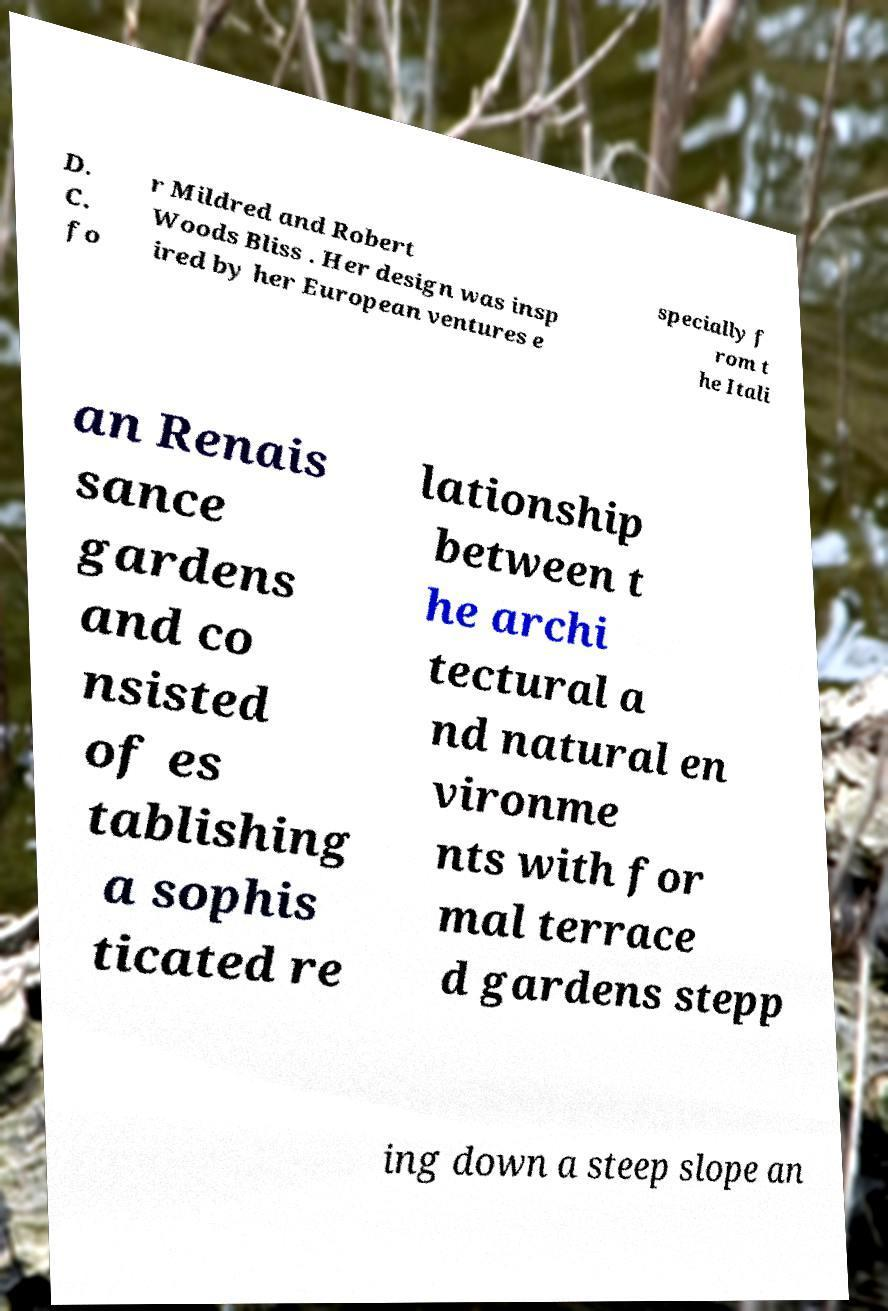Can you read and provide the text displayed in the image?This photo seems to have some interesting text. Can you extract and type it out for me? D. C. fo r Mildred and Robert Woods Bliss . Her design was insp ired by her European ventures e specially f rom t he Itali an Renais sance gardens and co nsisted of es tablishing a sophis ticated re lationship between t he archi tectural a nd natural en vironme nts with for mal terrace d gardens stepp ing down a steep slope an 